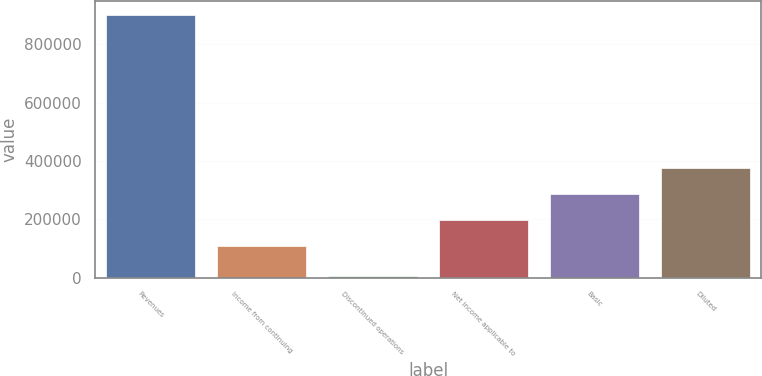Convert chart. <chart><loc_0><loc_0><loc_500><loc_500><bar_chart><fcel>Revenues<fcel>Income from continuing<fcel>Discontinued operations<fcel>Net income applicable to<fcel>Basic<fcel>Diluted<nl><fcel>902425<fcel>108430<fcel>5466<fcel>198126<fcel>287822<fcel>377518<nl></chart> 